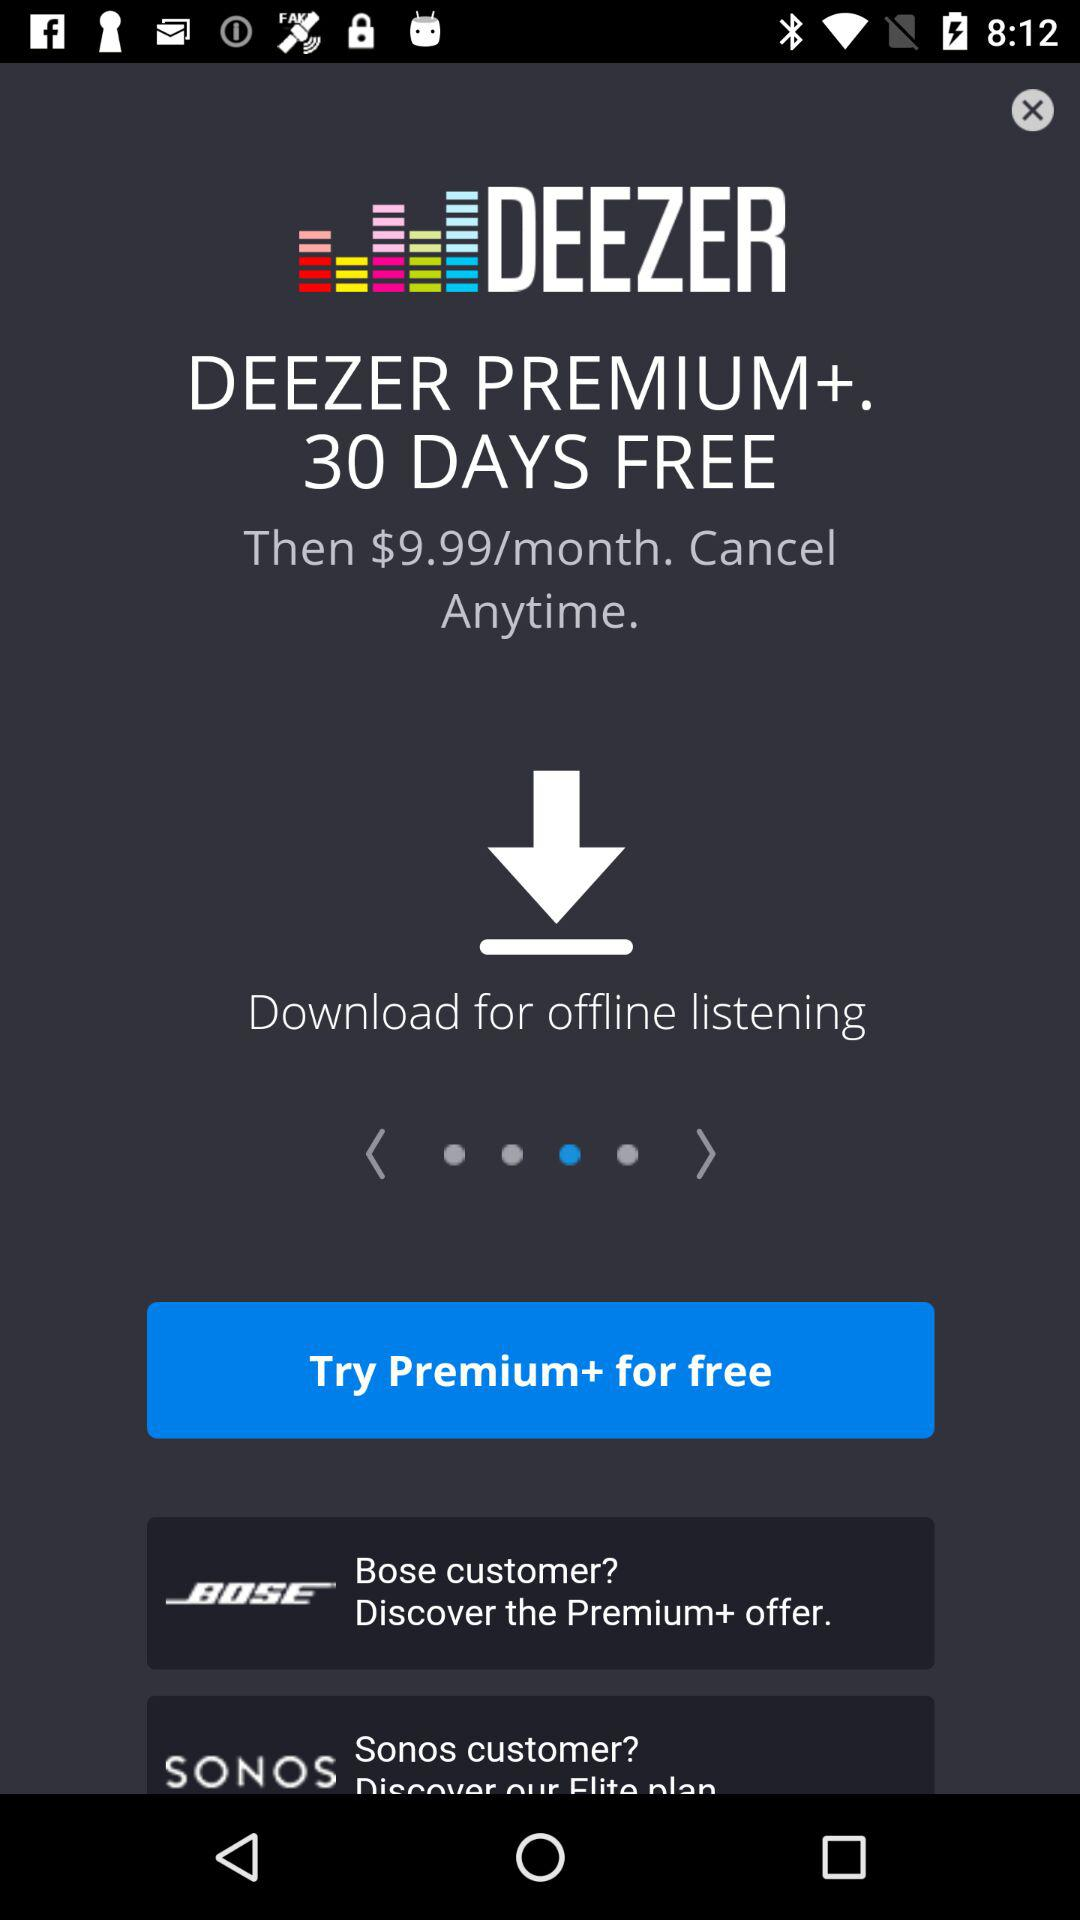How much more does a month of Deezer Premium+ cost than a month of Deezer Free?
Answer the question using a single word or phrase. $9.99 